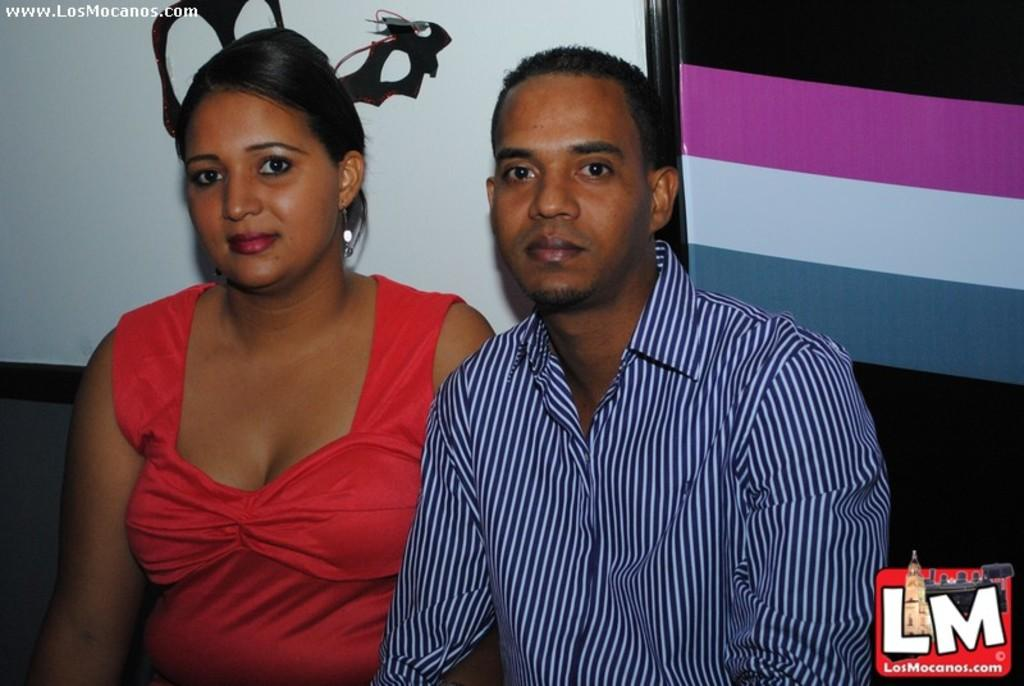Who are the people in the image? There is a man and a woman in the image. What are the man and the woman doing in the image? Both the man and the woman are sitting down. What can be seen in the background of the image? There is a wall in the background of the image. What type of feast is being prepared in the image? There is no indication of a feast or any food preparation in the image. Can you tell me how the war is affecting the people in the image? There is no mention of a war or any conflict in the image. 